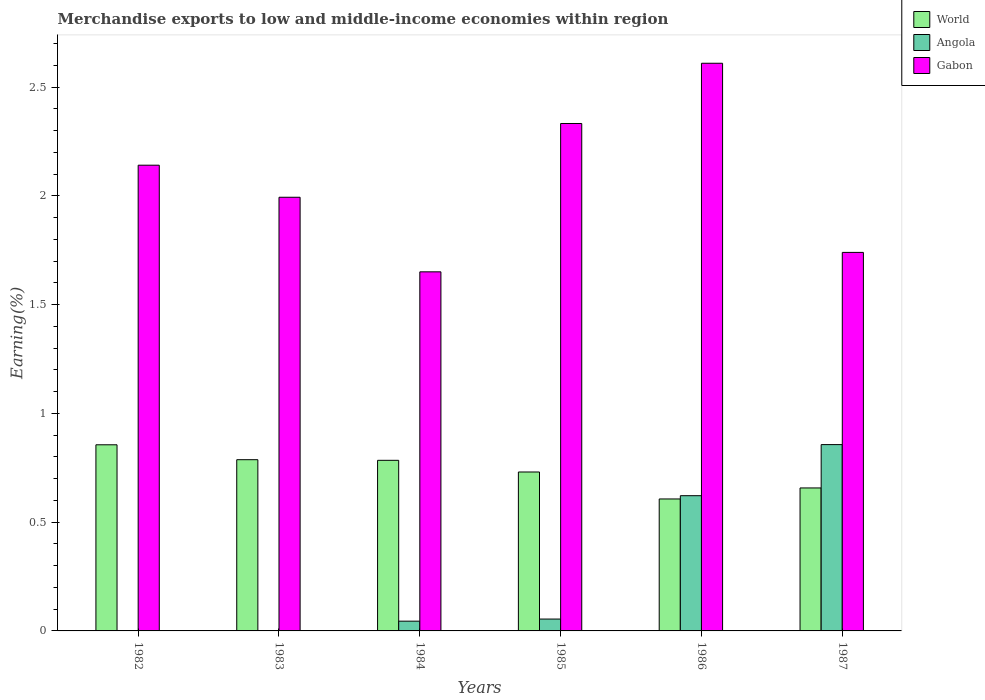How many groups of bars are there?
Give a very brief answer. 6. Are the number of bars on each tick of the X-axis equal?
Your response must be concise. Yes. How many bars are there on the 3rd tick from the left?
Keep it short and to the point. 3. What is the percentage of amount earned from merchandise exports in Angola in 1984?
Keep it short and to the point. 0.04. Across all years, what is the maximum percentage of amount earned from merchandise exports in Gabon?
Make the answer very short. 2.61. Across all years, what is the minimum percentage of amount earned from merchandise exports in Gabon?
Provide a short and direct response. 1.65. In which year was the percentage of amount earned from merchandise exports in World maximum?
Give a very brief answer. 1982. What is the total percentage of amount earned from merchandise exports in Angola in the graph?
Ensure brevity in your answer.  1.58. What is the difference between the percentage of amount earned from merchandise exports in Gabon in 1982 and that in 1985?
Provide a short and direct response. -0.19. What is the difference between the percentage of amount earned from merchandise exports in World in 1985 and the percentage of amount earned from merchandise exports in Gabon in 1984?
Offer a very short reply. -0.92. What is the average percentage of amount earned from merchandise exports in Gabon per year?
Your response must be concise. 2.08. In the year 1986, what is the difference between the percentage of amount earned from merchandise exports in Angola and percentage of amount earned from merchandise exports in Gabon?
Offer a terse response. -1.99. In how many years, is the percentage of amount earned from merchandise exports in Gabon greater than 0.8 %?
Provide a short and direct response. 6. What is the ratio of the percentage of amount earned from merchandise exports in World in 1982 to that in 1986?
Make the answer very short. 1.41. Is the difference between the percentage of amount earned from merchandise exports in Angola in 1982 and 1986 greater than the difference between the percentage of amount earned from merchandise exports in Gabon in 1982 and 1986?
Make the answer very short. No. What is the difference between the highest and the second highest percentage of amount earned from merchandise exports in Gabon?
Offer a very short reply. 0.28. What is the difference between the highest and the lowest percentage of amount earned from merchandise exports in World?
Provide a succinct answer. 0.25. In how many years, is the percentage of amount earned from merchandise exports in Angola greater than the average percentage of amount earned from merchandise exports in Angola taken over all years?
Your answer should be very brief. 2. Is the sum of the percentage of amount earned from merchandise exports in Gabon in 1983 and 1986 greater than the maximum percentage of amount earned from merchandise exports in World across all years?
Your answer should be very brief. Yes. How many bars are there?
Provide a succinct answer. 18. Are all the bars in the graph horizontal?
Your answer should be very brief. No. How many years are there in the graph?
Provide a short and direct response. 6. What is the difference between two consecutive major ticks on the Y-axis?
Give a very brief answer. 0.5. Are the values on the major ticks of Y-axis written in scientific E-notation?
Make the answer very short. No. Does the graph contain grids?
Provide a succinct answer. No. Where does the legend appear in the graph?
Offer a very short reply. Top right. How are the legend labels stacked?
Your answer should be very brief. Vertical. What is the title of the graph?
Ensure brevity in your answer.  Merchandise exports to low and middle-income economies within region. Does "Slovenia" appear as one of the legend labels in the graph?
Make the answer very short. No. What is the label or title of the Y-axis?
Offer a terse response. Earning(%). What is the Earning(%) of World in 1982?
Provide a succinct answer. 0.86. What is the Earning(%) of Angola in 1982?
Make the answer very short. 0. What is the Earning(%) of Gabon in 1982?
Offer a very short reply. 2.14. What is the Earning(%) of World in 1983?
Keep it short and to the point. 0.79. What is the Earning(%) of Angola in 1983?
Offer a very short reply. 0. What is the Earning(%) in Gabon in 1983?
Give a very brief answer. 1.99. What is the Earning(%) of World in 1984?
Provide a short and direct response. 0.78. What is the Earning(%) of Angola in 1984?
Ensure brevity in your answer.  0.04. What is the Earning(%) of Gabon in 1984?
Give a very brief answer. 1.65. What is the Earning(%) of World in 1985?
Keep it short and to the point. 0.73. What is the Earning(%) in Angola in 1985?
Offer a terse response. 0.05. What is the Earning(%) of Gabon in 1985?
Offer a very short reply. 2.33. What is the Earning(%) of World in 1986?
Give a very brief answer. 0.61. What is the Earning(%) of Angola in 1986?
Provide a short and direct response. 0.62. What is the Earning(%) of Gabon in 1986?
Provide a succinct answer. 2.61. What is the Earning(%) of World in 1987?
Your answer should be very brief. 0.66. What is the Earning(%) of Angola in 1987?
Keep it short and to the point. 0.86. What is the Earning(%) in Gabon in 1987?
Keep it short and to the point. 1.74. Across all years, what is the maximum Earning(%) in World?
Your response must be concise. 0.86. Across all years, what is the maximum Earning(%) in Angola?
Make the answer very short. 0.86. Across all years, what is the maximum Earning(%) in Gabon?
Offer a very short reply. 2.61. Across all years, what is the minimum Earning(%) of World?
Offer a very short reply. 0.61. Across all years, what is the minimum Earning(%) of Angola?
Ensure brevity in your answer.  0. Across all years, what is the minimum Earning(%) in Gabon?
Make the answer very short. 1.65. What is the total Earning(%) in World in the graph?
Make the answer very short. 4.42. What is the total Earning(%) of Angola in the graph?
Provide a succinct answer. 1.58. What is the total Earning(%) of Gabon in the graph?
Your answer should be very brief. 12.47. What is the difference between the Earning(%) of World in 1982 and that in 1983?
Your response must be concise. 0.07. What is the difference between the Earning(%) in Angola in 1982 and that in 1983?
Provide a succinct answer. -0. What is the difference between the Earning(%) in Gabon in 1982 and that in 1983?
Your answer should be very brief. 0.15. What is the difference between the Earning(%) of World in 1982 and that in 1984?
Your answer should be very brief. 0.07. What is the difference between the Earning(%) of Angola in 1982 and that in 1984?
Provide a short and direct response. -0.04. What is the difference between the Earning(%) in Gabon in 1982 and that in 1984?
Keep it short and to the point. 0.49. What is the difference between the Earning(%) in Angola in 1982 and that in 1985?
Give a very brief answer. -0.05. What is the difference between the Earning(%) of Gabon in 1982 and that in 1985?
Ensure brevity in your answer.  -0.19. What is the difference between the Earning(%) of World in 1982 and that in 1986?
Provide a short and direct response. 0.25. What is the difference between the Earning(%) in Angola in 1982 and that in 1986?
Ensure brevity in your answer.  -0.62. What is the difference between the Earning(%) in Gabon in 1982 and that in 1986?
Give a very brief answer. -0.47. What is the difference between the Earning(%) of World in 1982 and that in 1987?
Provide a short and direct response. 0.2. What is the difference between the Earning(%) of Angola in 1982 and that in 1987?
Ensure brevity in your answer.  -0.86. What is the difference between the Earning(%) in Gabon in 1982 and that in 1987?
Your answer should be very brief. 0.4. What is the difference between the Earning(%) of World in 1983 and that in 1984?
Keep it short and to the point. 0. What is the difference between the Earning(%) in Angola in 1983 and that in 1984?
Offer a very short reply. -0.04. What is the difference between the Earning(%) in Gabon in 1983 and that in 1984?
Your answer should be compact. 0.34. What is the difference between the Earning(%) of World in 1983 and that in 1985?
Your answer should be compact. 0.06. What is the difference between the Earning(%) of Angola in 1983 and that in 1985?
Your response must be concise. -0.05. What is the difference between the Earning(%) of Gabon in 1983 and that in 1985?
Make the answer very short. -0.34. What is the difference between the Earning(%) of World in 1983 and that in 1986?
Make the answer very short. 0.18. What is the difference between the Earning(%) of Angola in 1983 and that in 1986?
Your answer should be compact. -0.62. What is the difference between the Earning(%) of Gabon in 1983 and that in 1986?
Keep it short and to the point. -0.62. What is the difference between the Earning(%) in World in 1983 and that in 1987?
Your answer should be compact. 0.13. What is the difference between the Earning(%) of Angola in 1983 and that in 1987?
Your response must be concise. -0.86. What is the difference between the Earning(%) of Gabon in 1983 and that in 1987?
Offer a very short reply. 0.25. What is the difference between the Earning(%) in World in 1984 and that in 1985?
Offer a very short reply. 0.05. What is the difference between the Earning(%) in Angola in 1984 and that in 1985?
Keep it short and to the point. -0.01. What is the difference between the Earning(%) of Gabon in 1984 and that in 1985?
Make the answer very short. -0.68. What is the difference between the Earning(%) of World in 1984 and that in 1986?
Your answer should be compact. 0.18. What is the difference between the Earning(%) of Angola in 1984 and that in 1986?
Your answer should be very brief. -0.58. What is the difference between the Earning(%) in Gabon in 1984 and that in 1986?
Ensure brevity in your answer.  -0.96. What is the difference between the Earning(%) in World in 1984 and that in 1987?
Your response must be concise. 0.13. What is the difference between the Earning(%) in Angola in 1984 and that in 1987?
Keep it short and to the point. -0.81. What is the difference between the Earning(%) in Gabon in 1984 and that in 1987?
Your response must be concise. -0.09. What is the difference between the Earning(%) in World in 1985 and that in 1986?
Provide a succinct answer. 0.12. What is the difference between the Earning(%) in Angola in 1985 and that in 1986?
Ensure brevity in your answer.  -0.57. What is the difference between the Earning(%) in Gabon in 1985 and that in 1986?
Provide a short and direct response. -0.28. What is the difference between the Earning(%) in World in 1985 and that in 1987?
Offer a terse response. 0.07. What is the difference between the Earning(%) in Angola in 1985 and that in 1987?
Offer a very short reply. -0.8. What is the difference between the Earning(%) in Gabon in 1985 and that in 1987?
Keep it short and to the point. 0.59. What is the difference between the Earning(%) of World in 1986 and that in 1987?
Give a very brief answer. -0.05. What is the difference between the Earning(%) of Angola in 1986 and that in 1987?
Provide a succinct answer. -0.23. What is the difference between the Earning(%) in Gabon in 1986 and that in 1987?
Keep it short and to the point. 0.87. What is the difference between the Earning(%) in World in 1982 and the Earning(%) in Angola in 1983?
Offer a very short reply. 0.86. What is the difference between the Earning(%) in World in 1982 and the Earning(%) in Gabon in 1983?
Give a very brief answer. -1.14. What is the difference between the Earning(%) of Angola in 1982 and the Earning(%) of Gabon in 1983?
Offer a terse response. -1.99. What is the difference between the Earning(%) of World in 1982 and the Earning(%) of Angola in 1984?
Provide a succinct answer. 0.81. What is the difference between the Earning(%) in World in 1982 and the Earning(%) in Gabon in 1984?
Provide a succinct answer. -0.8. What is the difference between the Earning(%) of Angola in 1982 and the Earning(%) of Gabon in 1984?
Provide a succinct answer. -1.65. What is the difference between the Earning(%) of World in 1982 and the Earning(%) of Angola in 1985?
Your answer should be compact. 0.8. What is the difference between the Earning(%) in World in 1982 and the Earning(%) in Gabon in 1985?
Make the answer very short. -1.48. What is the difference between the Earning(%) in Angola in 1982 and the Earning(%) in Gabon in 1985?
Ensure brevity in your answer.  -2.33. What is the difference between the Earning(%) in World in 1982 and the Earning(%) in Angola in 1986?
Your response must be concise. 0.23. What is the difference between the Earning(%) of World in 1982 and the Earning(%) of Gabon in 1986?
Keep it short and to the point. -1.75. What is the difference between the Earning(%) of Angola in 1982 and the Earning(%) of Gabon in 1986?
Your answer should be compact. -2.61. What is the difference between the Earning(%) in World in 1982 and the Earning(%) in Angola in 1987?
Make the answer very short. -0. What is the difference between the Earning(%) of World in 1982 and the Earning(%) of Gabon in 1987?
Offer a terse response. -0.88. What is the difference between the Earning(%) of Angola in 1982 and the Earning(%) of Gabon in 1987?
Offer a terse response. -1.74. What is the difference between the Earning(%) of World in 1983 and the Earning(%) of Angola in 1984?
Provide a short and direct response. 0.74. What is the difference between the Earning(%) of World in 1983 and the Earning(%) of Gabon in 1984?
Keep it short and to the point. -0.86. What is the difference between the Earning(%) of Angola in 1983 and the Earning(%) of Gabon in 1984?
Keep it short and to the point. -1.65. What is the difference between the Earning(%) in World in 1983 and the Earning(%) in Angola in 1985?
Ensure brevity in your answer.  0.73. What is the difference between the Earning(%) in World in 1983 and the Earning(%) in Gabon in 1985?
Provide a short and direct response. -1.55. What is the difference between the Earning(%) in Angola in 1983 and the Earning(%) in Gabon in 1985?
Your answer should be compact. -2.33. What is the difference between the Earning(%) in World in 1983 and the Earning(%) in Angola in 1986?
Your answer should be compact. 0.17. What is the difference between the Earning(%) of World in 1983 and the Earning(%) of Gabon in 1986?
Your answer should be very brief. -1.82. What is the difference between the Earning(%) of Angola in 1983 and the Earning(%) of Gabon in 1986?
Offer a terse response. -2.61. What is the difference between the Earning(%) in World in 1983 and the Earning(%) in Angola in 1987?
Ensure brevity in your answer.  -0.07. What is the difference between the Earning(%) in World in 1983 and the Earning(%) in Gabon in 1987?
Keep it short and to the point. -0.95. What is the difference between the Earning(%) of Angola in 1983 and the Earning(%) of Gabon in 1987?
Ensure brevity in your answer.  -1.74. What is the difference between the Earning(%) of World in 1984 and the Earning(%) of Angola in 1985?
Your answer should be compact. 0.73. What is the difference between the Earning(%) of World in 1984 and the Earning(%) of Gabon in 1985?
Provide a succinct answer. -1.55. What is the difference between the Earning(%) of Angola in 1984 and the Earning(%) of Gabon in 1985?
Give a very brief answer. -2.29. What is the difference between the Earning(%) of World in 1984 and the Earning(%) of Angola in 1986?
Keep it short and to the point. 0.16. What is the difference between the Earning(%) in World in 1984 and the Earning(%) in Gabon in 1986?
Your response must be concise. -1.83. What is the difference between the Earning(%) of Angola in 1984 and the Earning(%) of Gabon in 1986?
Offer a terse response. -2.57. What is the difference between the Earning(%) in World in 1984 and the Earning(%) in Angola in 1987?
Make the answer very short. -0.07. What is the difference between the Earning(%) in World in 1984 and the Earning(%) in Gabon in 1987?
Your response must be concise. -0.96. What is the difference between the Earning(%) of Angola in 1984 and the Earning(%) of Gabon in 1987?
Provide a short and direct response. -1.7. What is the difference between the Earning(%) of World in 1985 and the Earning(%) of Angola in 1986?
Keep it short and to the point. 0.11. What is the difference between the Earning(%) of World in 1985 and the Earning(%) of Gabon in 1986?
Your answer should be very brief. -1.88. What is the difference between the Earning(%) of Angola in 1985 and the Earning(%) of Gabon in 1986?
Provide a succinct answer. -2.56. What is the difference between the Earning(%) in World in 1985 and the Earning(%) in Angola in 1987?
Your answer should be compact. -0.13. What is the difference between the Earning(%) in World in 1985 and the Earning(%) in Gabon in 1987?
Offer a terse response. -1.01. What is the difference between the Earning(%) in Angola in 1985 and the Earning(%) in Gabon in 1987?
Your response must be concise. -1.69. What is the difference between the Earning(%) of World in 1986 and the Earning(%) of Angola in 1987?
Your answer should be very brief. -0.25. What is the difference between the Earning(%) of World in 1986 and the Earning(%) of Gabon in 1987?
Offer a very short reply. -1.13. What is the difference between the Earning(%) in Angola in 1986 and the Earning(%) in Gabon in 1987?
Offer a very short reply. -1.12. What is the average Earning(%) of World per year?
Offer a terse response. 0.74. What is the average Earning(%) in Angola per year?
Provide a succinct answer. 0.26. What is the average Earning(%) of Gabon per year?
Offer a terse response. 2.08. In the year 1982, what is the difference between the Earning(%) in World and Earning(%) in Angola?
Provide a succinct answer. 0.86. In the year 1982, what is the difference between the Earning(%) in World and Earning(%) in Gabon?
Give a very brief answer. -1.29. In the year 1982, what is the difference between the Earning(%) of Angola and Earning(%) of Gabon?
Provide a succinct answer. -2.14. In the year 1983, what is the difference between the Earning(%) of World and Earning(%) of Angola?
Offer a very short reply. 0.79. In the year 1983, what is the difference between the Earning(%) in World and Earning(%) in Gabon?
Keep it short and to the point. -1.21. In the year 1983, what is the difference between the Earning(%) of Angola and Earning(%) of Gabon?
Make the answer very short. -1.99. In the year 1984, what is the difference between the Earning(%) of World and Earning(%) of Angola?
Make the answer very short. 0.74. In the year 1984, what is the difference between the Earning(%) in World and Earning(%) in Gabon?
Provide a short and direct response. -0.87. In the year 1984, what is the difference between the Earning(%) of Angola and Earning(%) of Gabon?
Offer a very short reply. -1.61. In the year 1985, what is the difference between the Earning(%) of World and Earning(%) of Angola?
Your answer should be very brief. 0.68. In the year 1985, what is the difference between the Earning(%) in World and Earning(%) in Gabon?
Keep it short and to the point. -1.6. In the year 1985, what is the difference between the Earning(%) of Angola and Earning(%) of Gabon?
Keep it short and to the point. -2.28. In the year 1986, what is the difference between the Earning(%) of World and Earning(%) of Angola?
Your answer should be very brief. -0.01. In the year 1986, what is the difference between the Earning(%) in World and Earning(%) in Gabon?
Your answer should be very brief. -2. In the year 1986, what is the difference between the Earning(%) in Angola and Earning(%) in Gabon?
Keep it short and to the point. -1.99. In the year 1987, what is the difference between the Earning(%) in World and Earning(%) in Angola?
Give a very brief answer. -0.2. In the year 1987, what is the difference between the Earning(%) in World and Earning(%) in Gabon?
Offer a terse response. -1.08. In the year 1987, what is the difference between the Earning(%) in Angola and Earning(%) in Gabon?
Provide a short and direct response. -0.88. What is the ratio of the Earning(%) in World in 1982 to that in 1983?
Ensure brevity in your answer.  1.09. What is the ratio of the Earning(%) of Angola in 1982 to that in 1983?
Your response must be concise. 0.5. What is the ratio of the Earning(%) of Gabon in 1982 to that in 1983?
Keep it short and to the point. 1.07. What is the ratio of the Earning(%) of World in 1982 to that in 1984?
Ensure brevity in your answer.  1.09. What is the ratio of the Earning(%) in Angola in 1982 to that in 1984?
Offer a terse response. 0.01. What is the ratio of the Earning(%) in Gabon in 1982 to that in 1984?
Give a very brief answer. 1.3. What is the ratio of the Earning(%) in World in 1982 to that in 1985?
Your answer should be compact. 1.17. What is the ratio of the Earning(%) of Angola in 1982 to that in 1985?
Make the answer very short. 0.01. What is the ratio of the Earning(%) of Gabon in 1982 to that in 1985?
Offer a very short reply. 0.92. What is the ratio of the Earning(%) of World in 1982 to that in 1986?
Make the answer very short. 1.41. What is the ratio of the Earning(%) of Gabon in 1982 to that in 1986?
Ensure brevity in your answer.  0.82. What is the ratio of the Earning(%) of World in 1982 to that in 1987?
Ensure brevity in your answer.  1.3. What is the ratio of the Earning(%) in Angola in 1982 to that in 1987?
Provide a short and direct response. 0. What is the ratio of the Earning(%) of Gabon in 1982 to that in 1987?
Your answer should be very brief. 1.23. What is the ratio of the Earning(%) in World in 1983 to that in 1984?
Provide a short and direct response. 1. What is the ratio of the Earning(%) in Angola in 1983 to that in 1984?
Keep it short and to the point. 0.01. What is the ratio of the Earning(%) in Gabon in 1983 to that in 1984?
Your answer should be very brief. 1.21. What is the ratio of the Earning(%) in World in 1983 to that in 1985?
Provide a short and direct response. 1.08. What is the ratio of the Earning(%) of Angola in 1983 to that in 1985?
Provide a short and direct response. 0.01. What is the ratio of the Earning(%) of Gabon in 1983 to that in 1985?
Offer a terse response. 0.85. What is the ratio of the Earning(%) of World in 1983 to that in 1986?
Your response must be concise. 1.3. What is the ratio of the Earning(%) in Angola in 1983 to that in 1986?
Your answer should be compact. 0. What is the ratio of the Earning(%) in Gabon in 1983 to that in 1986?
Provide a short and direct response. 0.76. What is the ratio of the Earning(%) in World in 1983 to that in 1987?
Offer a very short reply. 1.2. What is the ratio of the Earning(%) of Angola in 1983 to that in 1987?
Give a very brief answer. 0. What is the ratio of the Earning(%) in Gabon in 1983 to that in 1987?
Keep it short and to the point. 1.15. What is the ratio of the Earning(%) of World in 1984 to that in 1985?
Provide a short and direct response. 1.07. What is the ratio of the Earning(%) of Angola in 1984 to that in 1985?
Keep it short and to the point. 0.82. What is the ratio of the Earning(%) of Gabon in 1984 to that in 1985?
Your response must be concise. 0.71. What is the ratio of the Earning(%) of World in 1984 to that in 1986?
Make the answer very short. 1.29. What is the ratio of the Earning(%) of Angola in 1984 to that in 1986?
Your answer should be very brief. 0.07. What is the ratio of the Earning(%) in Gabon in 1984 to that in 1986?
Keep it short and to the point. 0.63. What is the ratio of the Earning(%) in World in 1984 to that in 1987?
Make the answer very short. 1.19. What is the ratio of the Earning(%) of Angola in 1984 to that in 1987?
Provide a short and direct response. 0.05. What is the ratio of the Earning(%) of Gabon in 1984 to that in 1987?
Make the answer very short. 0.95. What is the ratio of the Earning(%) in World in 1985 to that in 1986?
Make the answer very short. 1.2. What is the ratio of the Earning(%) of Angola in 1985 to that in 1986?
Offer a very short reply. 0.09. What is the ratio of the Earning(%) in Gabon in 1985 to that in 1986?
Your answer should be very brief. 0.89. What is the ratio of the Earning(%) in World in 1985 to that in 1987?
Make the answer very short. 1.11. What is the ratio of the Earning(%) of Angola in 1985 to that in 1987?
Provide a succinct answer. 0.06. What is the ratio of the Earning(%) in Gabon in 1985 to that in 1987?
Your response must be concise. 1.34. What is the ratio of the Earning(%) of World in 1986 to that in 1987?
Keep it short and to the point. 0.92. What is the ratio of the Earning(%) of Angola in 1986 to that in 1987?
Provide a succinct answer. 0.73. What is the ratio of the Earning(%) of Gabon in 1986 to that in 1987?
Your answer should be compact. 1.5. What is the difference between the highest and the second highest Earning(%) in World?
Ensure brevity in your answer.  0.07. What is the difference between the highest and the second highest Earning(%) in Angola?
Offer a very short reply. 0.23. What is the difference between the highest and the second highest Earning(%) in Gabon?
Make the answer very short. 0.28. What is the difference between the highest and the lowest Earning(%) in World?
Offer a terse response. 0.25. What is the difference between the highest and the lowest Earning(%) of Angola?
Ensure brevity in your answer.  0.86. 